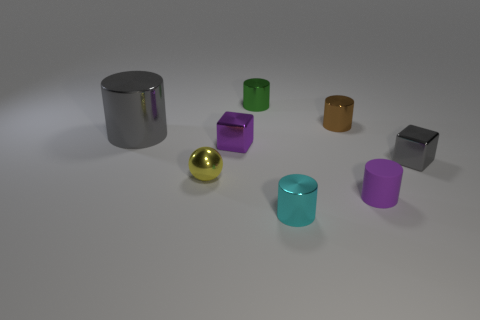Is there any other thing that has the same material as the small purple cylinder?
Ensure brevity in your answer.  No. What is the cylinder that is left of the brown metallic cylinder and in front of the small ball made of?
Keep it short and to the point. Metal. There is a tiny metal block in front of the tiny purple metal block; is it the same color as the large shiny cylinder?
Give a very brief answer. Yes. Do the tiny matte cylinder and the small metal cube that is to the left of the small purple matte object have the same color?
Offer a very short reply. Yes. Are there any small cyan metallic things in front of the gray cylinder?
Give a very brief answer. Yes. Is the tiny green object made of the same material as the purple cylinder?
Provide a short and direct response. No. There is a yellow ball that is the same size as the cyan metallic thing; what is its material?
Your response must be concise. Metal. How many objects are either tiny metal things that are behind the small brown metallic cylinder or cyan things?
Offer a terse response. 2. Are there the same number of tiny cyan shiny cylinders that are to the right of the small yellow sphere and big purple cubes?
Ensure brevity in your answer.  No. Is the color of the rubber cylinder the same as the small ball?
Your answer should be very brief. No. 